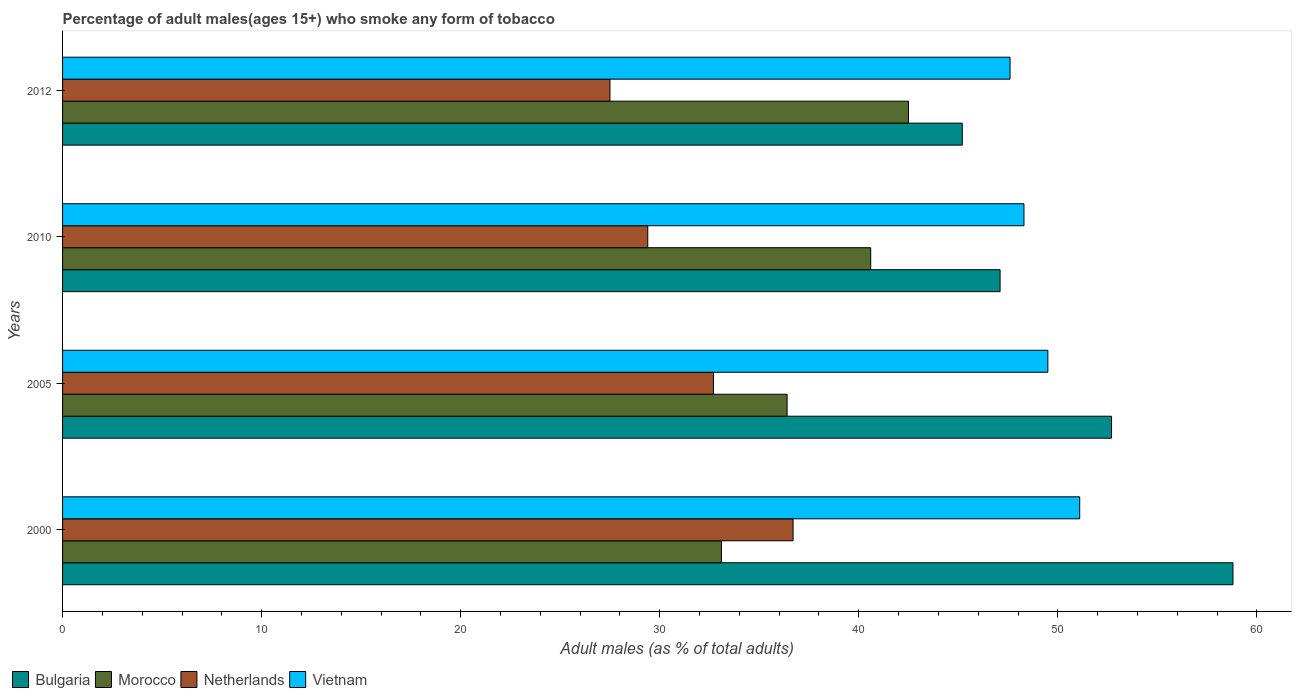How many different coloured bars are there?
Your answer should be very brief. 4. How many groups of bars are there?
Keep it short and to the point. 4. Are the number of bars per tick equal to the number of legend labels?
Offer a terse response. Yes. Are the number of bars on each tick of the Y-axis equal?
Keep it short and to the point. Yes. What is the label of the 3rd group of bars from the top?
Offer a very short reply. 2005. What is the percentage of adult males who smoke in Morocco in 2005?
Your answer should be compact. 36.4. Across all years, what is the maximum percentage of adult males who smoke in Morocco?
Your response must be concise. 42.5. Across all years, what is the minimum percentage of adult males who smoke in Vietnam?
Your answer should be compact. 47.6. In which year was the percentage of adult males who smoke in Bulgaria maximum?
Your response must be concise. 2000. What is the total percentage of adult males who smoke in Bulgaria in the graph?
Your response must be concise. 203.8. What is the difference between the percentage of adult males who smoke in Morocco in 2005 and the percentage of adult males who smoke in Bulgaria in 2012?
Offer a terse response. -8.8. What is the average percentage of adult males who smoke in Bulgaria per year?
Make the answer very short. 50.95. In the year 2012, what is the difference between the percentage of adult males who smoke in Netherlands and percentage of adult males who smoke in Vietnam?
Your response must be concise. -20.1. In how many years, is the percentage of adult males who smoke in Morocco greater than 16 %?
Make the answer very short. 4. What is the ratio of the percentage of adult males who smoke in Vietnam in 2005 to that in 2012?
Keep it short and to the point. 1.04. Is the percentage of adult males who smoke in Vietnam in 2000 less than that in 2010?
Keep it short and to the point. No. Is the sum of the percentage of adult males who smoke in Bulgaria in 2005 and 2012 greater than the maximum percentage of adult males who smoke in Vietnam across all years?
Your answer should be compact. Yes. Is it the case that in every year, the sum of the percentage of adult males who smoke in Morocco and percentage of adult males who smoke in Netherlands is greater than the sum of percentage of adult males who smoke in Bulgaria and percentage of adult males who smoke in Vietnam?
Your answer should be compact. No. What does the 4th bar from the top in 2000 represents?
Keep it short and to the point. Bulgaria. What does the 4th bar from the bottom in 2000 represents?
Give a very brief answer. Vietnam. How many bars are there?
Your answer should be very brief. 16. How many years are there in the graph?
Your answer should be very brief. 4. What is the difference between two consecutive major ticks on the X-axis?
Offer a very short reply. 10. Does the graph contain any zero values?
Make the answer very short. No. Where does the legend appear in the graph?
Keep it short and to the point. Bottom left. How are the legend labels stacked?
Offer a terse response. Horizontal. What is the title of the graph?
Offer a very short reply. Percentage of adult males(ages 15+) who smoke any form of tobacco. Does "Barbados" appear as one of the legend labels in the graph?
Ensure brevity in your answer.  No. What is the label or title of the X-axis?
Keep it short and to the point. Adult males (as % of total adults). What is the Adult males (as % of total adults) of Bulgaria in 2000?
Provide a succinct answer. 58.8. What is the Adult males (as % of total adults) of Morocco in 2000?
Make the answer very short. 33.1. What is the Adult males (as % of total adults) in Netherlands in 2000?
Offer a terse response. 36.7. What is the Adult males (as % of total adults) of Vietnam in 2000?
Offer a very short reply. 51.1. What is the Adult males (as % of total adults) of Bulgaria in 2005?
Provide a succinct answer. 52.7. What is the Adult males (as % of total adults) in Morocco in 2005?
Your answer should be very brief. 36.4. What is the Adult males (as % of total adults) in Netherlands in 2005?
Your response must be concise. 32.7. What is the Adult males (as % of total adults) in Vietnam in 2005?
Your response must be concise. 49.5. What is the Adult males (as % of total adults) of Bulgaria in 2010?
Offer a very short reply. 47.1. What is the Adult males (as % of total adults) of Morocco in 2010?
Keep it short and to the point. 40.6. What is the Adult males (as % of total adults) in Netherlands in 2010?
Give a very brief answer. 29.4. What is the Adult males (as % of total adults) of Vietnam in 2010?
Keep it short and to the point. 48.3. What is the Adult males (as % of total adults) of Bulgaria in 2012?
Your response must be concise. 45.2. What is the Adult males (as % of total adults) in Morocco in 2012?
Offer a very short reply. 42.5. What is the Adult males (as % of total adults) in Netherlands in 2012?
Offer a terse response. 27.5. What is the Adult males (as % of total adults) in Vietnam in 2012?
Your answer should be compact. 47.6. Across all years, what is the maximum Adult males (as % of total adults) of Bulgaria?
Offer a terse response. 58.8. Across all years, what is the maximum Adult males (as % of total adults) in Morocco?
Your answer should be very brief. 42.5. Across all years, what is the maximum Adult males (as % of total adults) in Netherlands?
Your response must be concise. 36.7. Across all years, what is the maximum Adult males (as % of total adults) in Vietnam?
Ensure brevity in your answer.  51.1. Across all years, what is the minimum Adult males (as % of total adults) in Bulgaria?
Make the answer very short. 45.2. Across all years, what is the minimum Adult males (as % of total adults) of Morocco?
Your answer should be compact. 33.1. Across all years, what is the minimum Adult males (as % of total adults) of Netherlands?
Your answer should be very brief. 27.5. Across all years, what is the minimum Adult males (as % of total adults) of Vietnam?
Provide a short and direct response. 47.6. What is the total Adult males (as % of total adults) of Bulgaria in the graph?
Provide a short and direct response. 203.8. What is the total Adult males (as % of total adults) of Morocco in the graph?
Your answer should be very brief. 152.6. What is the total Adult males (as % of total adults) of Netherlands in the graph?
Keep it short and to the point. 126.3. What is the total Adult males (as % of total adults) of Vietnam in the graph?
Make the answer very short. 196.5. What is the difference between the Adult males (as % of total adults) in Bulgaria in 2000 and that in 2005?
Keep it short and to the point. 6.1. What is the difference between the Adult males (as % of total adults) of Morocco in 2000 and that in 2005?
Make the answer very short. -3.3. What is the difference between the Adult males (as % of total adults) of Netherlands in 2000 and that in 2005?
Offer a very short reply. 4. What is the difference between the Adult males (as % of total adults) of Morocco in 2000 and that in 2010?
Your answer should be very brief. -7.5. What is the difference between the Adult males (as % of total adults) of Vietnam in 2000 and that in 2010?
Keep it short and to the point. 2.8. What is the difference between the Adult males (as % of total adults) of Bulgaria in 2000 and that in 2012?
Your response must be concise. 13.6. What is the difference between the Adult males (as % of total adults) of Morocco in 2005 and that in 2010?
Your answer should be very brief. -4.2. What is the difference between the Adult males (as % of total adults) in Netherlands in 2005 and that in 2010?
Provide a succinct answer. 3.3. What is the difference between the Adult males (as % of total adults) of Vietnam in 2005 and that in 2010?
Your answer should be very brief. 1.2. What is the difference between the Adult males (as % of total adults) of Morocco in 2005 and that in 2012?
Offer a terse response. -6.1. What is the difference between the Adult males (as % of total adults) in Netherlands in 2005 and that in 2012?
Give a very brief answer. 5.2. What is the difference between the Adult males (as % of total adults) in Vietnam in 2005 and that in 2012?
Provide a short and direct response. 1.9. What is the difference between the Adult males (as % of total adults) in Bulgaria in 2010 and that in 2012?
Keep it short and to the point. 1.9. What is the difference between the Adult males (as % of total adults) of Morocco in 2010 and that in 2012?
Your response must be concise. -1.9. What is the difference between the Adult males (as % of total adults) in Vietnam in 2010 and that in 2012?
Offer a terse response. 0.7. What is the difference between the Adult males (as % of total adults) of Bulgaria in 2000 and the Adult males (as % of total adults) of Morocco in 2005?
Your answer should be compact. 22.4. What is the difference between the Adult males (as % of total adults) in Bulgaria in 2000 and the Adult males (as % of total adults) in Netherlands in 2005?
Your response must be concise. 26.1. What is the difference between the Adult males (as % of total adults) in Bulgaria in 2000 and the Adult males (as % of total adults) in Vietnam in 2005?
Give a very brief answer. 9.3. What is the difference between the Adult males (as % of total adults) in Morocco in 2000 and the Adult males (as % of total adults) in Vietnam in 2005?
Give a very brief answer. -16.4. What is the difference between the Adult males (as % of total adults) of Netherlands in 2000 and the Adult males (as % of total adults) of Vietnam in 2005?
Your response must be concise. -12.8. What is the difference between the Adult males (as % of total adults) in Bulgaria in 2000 and the Adult males (as % of total adults) in Morocco in 2010?
Make the answer very short. 18.2. What is the difference between the Adult males (as % of total adults) in Bulgaria in 2000 and the Adult males (as % of total adults) in Netherlands in 2010?
Your answer should be compact. 29.4. What is the difference between the Adult males (as % of total adults) in Morocco in 2000 and the Adult males (as % of total adults) in Netherlands in 2010?
Give a very brief answer. 3.7. What is the difference between the Adult males (as % of total adults) in Morocco in 2000 and the Adult males (as % of total adults) in Vietnam in 2010?
Offer a terse response. -15.2. What is the difference between the Adult males (as % of total adults) in Netherlands in 2000 and the Adult males (as % of total adults) in Vietnam in 2010?
Offer a terse response. -11.6. What is the difference between the Adult males (as % of total adults) in Bulgaria in 2000 and the Adult males (as % of total adults) in Netherlands in 2012?
Offer a terse response. 31.3. What is the difference between the Adult males (as % of total adults) in Bulgaria in 2000 and the Adult males (as % of total adults) in Vietnam in 2012?
Your answer should be compact. 11.2. What is the difference between the Adult males (as % of total adults) in Morocco in 2000 and the Adult males (as % of total adults) in Vietnam in 2012?
Your answer should be compact. -14.5. What is the difference between the Adult males (as % of total adults) in Netherlands in 2000 and the Adult males (as % of total adults) in Vietnam in 2012?
Your answer should be compact. -10.9. What is the difference between the Adult males (as % of total adults) in Bulgaria in 2005 and the Adult males (as % of total adults) in Morocco in 2010?
Offer a very short reply. 12.1. What is the difference between the Adult males (as % of total adults) of Bulgaria in 2005 and the Adult males (as % of total adults) of Netherlands in 2010?
Give a very brief answer. 23.3. What is the difference between the Adult males (as % of total adults) of Netherlands in 2005 and the Adult males (as % of total adults) of Vietnam in 2010?
Your answer should be very brief. -15.6. What is the difference between the Adult males (as % of total adults) in Bulgaria in 2005 and the Adult males (as % of total adults) in Netherlands in 2012?
Provide a succinct answer. 25.2. What is the difference between the Adult males (as % of total adults) of Morocco in 2005 and the Adult males (as % of total adults) of Vietnam in 2012?
Keep it short and to the point. -11.2. What is the difference between the Adult males (as % of total adults) in Netherlands in 2005 and the Adult males (as % of total adults) in Vietnam in 2012?
Make the answer very short. -14.9. What is the difference between the Adult males (as % of total adults) of Bulgaria in 2010 and the Adult males (as % of total adults) of Morocco in 2012?
Make the answer very short. 4.6. What is the difference between the Adult males (as % of total adults) of Bulgaria in 2010 and the Adult males (as % of total adults) of Netherlands in 2012?
Your response must be concise. 19.6. What is the difference between the Adult males (as % of total adults) in Morocco in 2010 and the Adult males (as % of total adults) in Vietnam in 2012?
Provide a short and direct response. -7. What is the difference between the Adult males (as % of total adults) of Netherlands in 2010 and the Adult males (as % of total adults) of Vietnam in 2012?
Ensure brevity in your answer.  -18.2. What is the average Adult males (as % of total adults) in Bulgaria per year?
Offer a very short reply. 50.95. What is the average Adult males (as % of total adults) in Morocco per year?
Ensure brevity in your answer.  38.15. What is the average Adult males (as % of total adults) of Netherlands per year?
Make the answer very short. 31.57. What is the average Adult males (as % of total adults) in Vietnam per year?
Your answer should be compact. 49.12. In the year 2000, what is the difference between the Adult males (as % of total adults) in Bulgaria and Adult males (as % of total adults) in Morocco?
Make the answer very short. 25.7. In the year 2000, what is the difference between the Adult males (as % of total adults) of Bulgaria and Adult males (as % of total adults) of Netherlands?
Give a very brief answer. 22.1. In the year 2000, what is the difference between the Adult males (as % of total adults) of Morocco and Adult males (as % of total adults) of Vietnam?
Give a very brief answer. -18. In the year 2000, what is the difference between the Adult males (as % of total adults) of Netherlands and Adult males (as % of total adults) of Vietnam?
Ensure brevity in your answer.  -14.4. In the year 2005, what is the difference between the Adult males (as % of total adults) in Morocco and Adult males (as % of total adults) in Vietnam?
Make the answer very short. -13.1. In the year 2005, what is the difference between the Adult males (as % of total adults) of Netherlands and Adult males (as % of total adults) of Vietnam?
Your answer should be very brief. -16.8. In the year 2010, what is the difference between the Adult males (as % of total adults) of Morocco and Adult males (as % of total adults) of Netherlands?
Offer a very short reply. 11.2. In the year 2010, what is the difference between the Adult males (as % of total adults) in Netherlands and Adult males (as % of total adults) in Vietnam?
Give a very brief answer. -18.9. In the year 2012, what is the difference between the Adult males (as % of total adults) of Bulgaria and Adult males (as % of total adults) of Morocco?
Provide a short and direct response. 2.7. In the year 2012, what is the difference between the Adult males (as % of total adults) in Bulgaria and Adult males (as % of total adults) in Vietnam?
Your response must be concise. -2.4. In the year 2012, what is the difference between the Adult males (as % of total adults) in Netherlands and Adult males (as % of total adults) in Vietnam?
Your answer should be compact. -20.1. What is the ratio of the Adult males (as % of total adults) in Bulgaria in 2000 to that in 2005?
Provide a short and direct response. 1.12. What is the ratio of the Adult males (as % of total adults) in Morocco in 2000 to that in 2005?
Your response must be concise. 0.91. What is the ratio of the Adult males (as % of total adults) of Netherlands in 2000 to that in 2005?
Give a very brief answer. 1.12. What is the ratio of the Adult males (as % of total adults) in Vietnam in 2000 to that in 2005?
Give a very brief answer. 1.03. What is the ratio of the Adult males (as % of total adults) in Bulgaria in 2000 to that in 2010?
Provide a short and direct response. 1.25. What is the ratio of the Adult males (as % of total adults) of Morocco in 2000 to that in 2010?
Your answer should be compact. 0.82. What is the ratio of the Adult males (as % of total adults) in Netherlands in 2000 to that in 2010?
Provide a succinct answer. 1.25. What is the ratio of the Adult males (as % of total adults) of Vietnam in 2000 to that in 2010?
Your response must be concise. 1.06. What is the ratio of the Adult males (as % of total adults) of Bulgaria in 2000 to that in 2012?
Your response must be concise. 1.3. What is the ratio of the Adult males (as % of total adults) of Morocco in 2000 to that in 2012?
Provide a short and direct response. 0.78. What is the ratio of the Adult males (as % of total adults) of Netherlands in 2000 to that in 2012?
Keep it short and to the point. 1.33. What is the ratio of the Adult males (as % of total adults) of Vietnam in 2000 to that in 2012?
Give a very brief answer. 1.07. What is the ratio of the Adult males (as % of total adults) of Bulgaria in 2005 to that in 2010?
Your answer should be very brief. 1.12. What is the ratio of the Adult males (as % of total adults) of Morocco in 2005 to that in 2010?
Give a very brief answer. 0.9. What is the ratio of the Adult males (as % of total adults) in Netherlands in 2005 to that in 2010?
Make the answer very short. 1.11. What is the ratio of the Adult males (as % of total adults) of Vietnam in 2005 to that in 2010?
Provide a succinct answer. 1.02. What is the ratio of the Adult males (as % of total adults) of Bulgaria in 2005 to that in 2012?
Give a very brief answer. 1.17. What is the ratio of the Adult males (as % of total adults) in Morocco in 2005 to that in 2012?
Your response must be concise. 0.86. What is the ratio of the Adult males (as % of total adults) in Netherlands in 2005 to that in 2012?
Make the answer very short. 1.19. What is the ratio of the Adult males (as % of total adults) in Vietnam in 2005 to that in 2012?
Offer a terse response. 1.04. What is the ratio of the Adult males (as % of total adults) in Bulgaria in 2010 to that in 2012?
Provide a short and direct response. 1.04. What is the ratio of the Adult males (as % of total adults) of Morocco in 2010 to that in 2012?
Your answer should be very brief. 0.96. What is the ratio of the Adult males (as % of total adults) of Netherlands in 2010 to that in 2012?
Offer a very short reply. 1.07. What is the ratio of the Adult males (as % of total adults) in Vietnam in 2010 to that in 2012?
Make the answer very short. 1.01. What is the difference between the highest and the second highest Adult males (as % of total adults) in Morocco?
Offer a terse response. 1.9. What is the difference between the highest and the second highest Adult males (as % of total adults) in Vietnam?
Offer a terse response. 1.6. What is the difference between the highest and the lowest Adult males (as % of total adults) of Netherlands?
Offer a terse response. 9.2. What is the difference between the highest and the lowest Adult males (as % of total adults) in Vietnam?
Offer a very short reply. 3.5. 